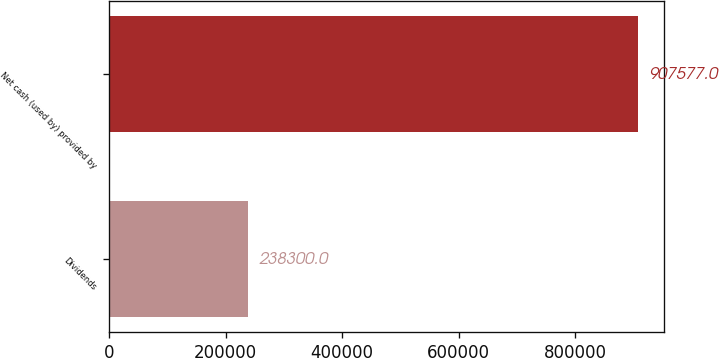<chart> <loc_0><loc_0><loc_500><loc_500><bar_chart><fcel>Dividends<fcel>Net cash (used by) provided by<nl><fcel>238300<fcel>907577<nl></chart> 